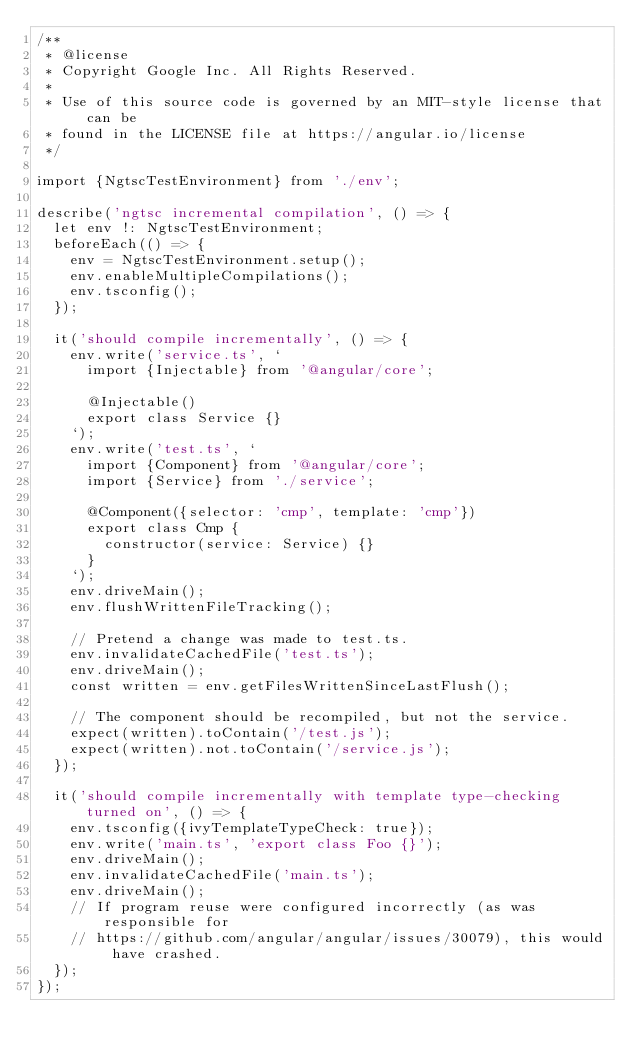Convert code to text. <code><loc_0><loc_0><loc_500><loc_500><_TypeScript_>/**
 * @license
 * Copyright Google Inc. All Rights Reserved.
 *
 * Use of this source code is governed by an MIT-style license that can be
 * found in the LICENSE file at https://angular.io/license
 */

import {NgtscTestEnvironment} from './env';

describe('ngtsc incremental compilation', () => {
  let env !: NgtscTestEnvironment;
  beforeEach(() => {
    env = NgtscTestEnvironment.setup();
    env.enableMultipleCompilations();
    env.tsconfig();
  });

  it('should compile incrementally', () => {
    env.write('service.ts', `
      import {Injectable} from '@angular/core';

      @Injectable()
      export class Service {}
    `);
    env.write('test.ts', `
      import {Component} from '@angular/core';
      import {Service} from './service';

      @Component({selector: 'cmp', template: 'cmp'})
      export class Cmp {
        constructor(service: Service) {}
      }
    `);
    env.driveMain();
    env.flushWrittenFileTracking();

    // Pretend a change was made to test.ts.
    env.invalidateCachedFile('test.ts');
    env.driveMain();
    const written = env.getFilesWrittenSinceLastFlush();

    // The component should be recompiled, but not the service.
    expect(written).toContain('/test.js');
    expect(written).not.toContain('/service.js');
  });

  it('should compile incrementally with template type-checking turned on', () => {
    env.tsconfig({ivyTemplateTypeCheck: true});
    env.write('main.ts', 'export class Foo {}');
    env.driveMain();
    env.invalidateCachedFile('main.ts');
    env.driveMain();
    // If program reuse were configured incorrectly (as was responsible for
    // https://github.com/angular/angular/issues/30079), this would have crashed.
  });
});</code> 